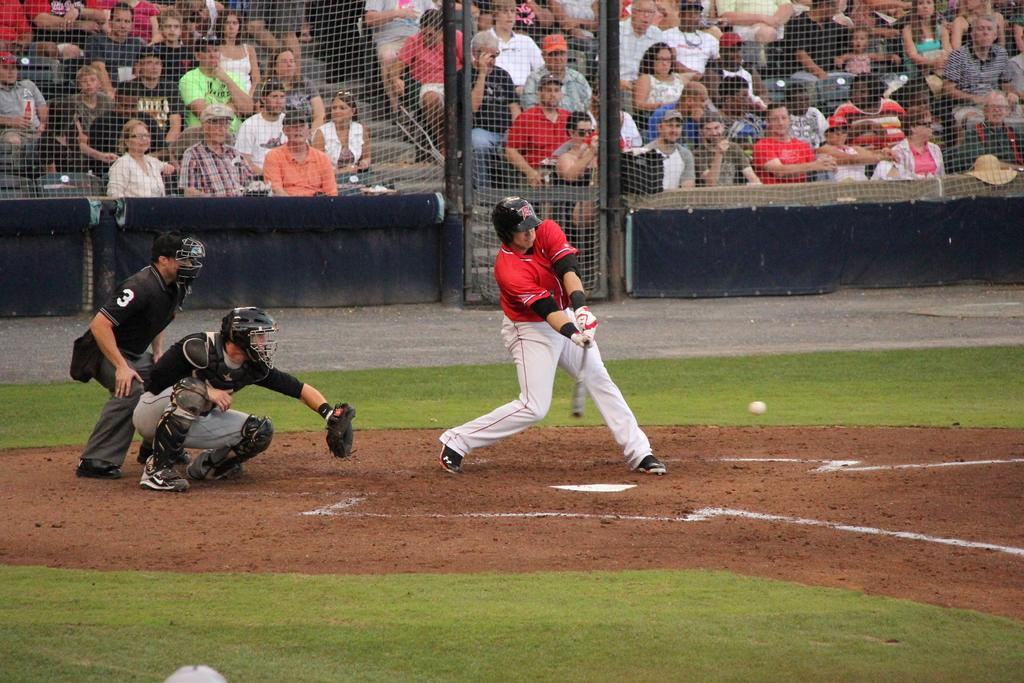<image>
Provide a brief description of the given image. a player getting ready to hit a ball with an R on their helmet 